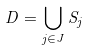Convert formula to latex. <formula><loc_0><loc_0><loc_500><loc_500>D = \bigcup _ { j \in J } S _ { j }</formula> 